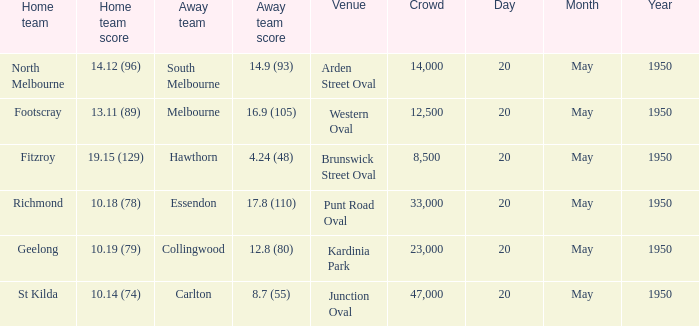Which team was the away team when the game was at punt road oval? Essendon. 